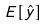<formula> <loc_0><loc_0><loc_500><loc_500>E [ \hat { y } ]</formula> 